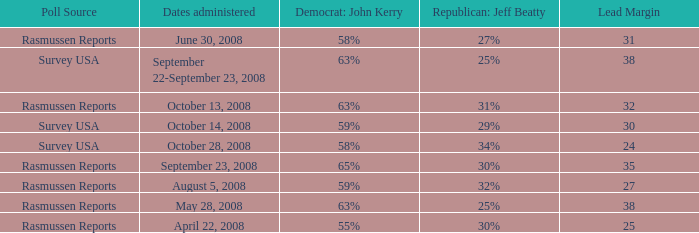What are the dates where democrat john kerry is 63% and poll source is rasmussen reports? October 13, 2008, May 28, 2008. 